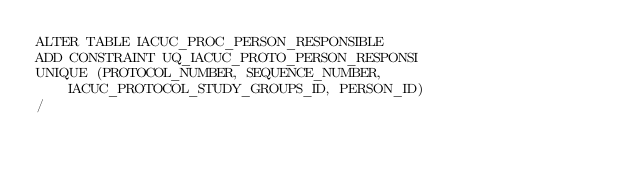Convert code to text. <code><loc_0><loc_0><loc_500><loc_500><_SQL_>ALTER TABLE IACUC_PROC_PERSON_RESPONSIBLE 
ADD CONSTRAINT UQ_IACUC_PROTO_PERSON_RESPONSI 
UNIQUE (PROTOCOL_NUMBER, SEQUENCE_NUMBER, IACUC_PROTOCOL_STUDY_GROUPS_ID, PERSON_ID) 
/

</code> 